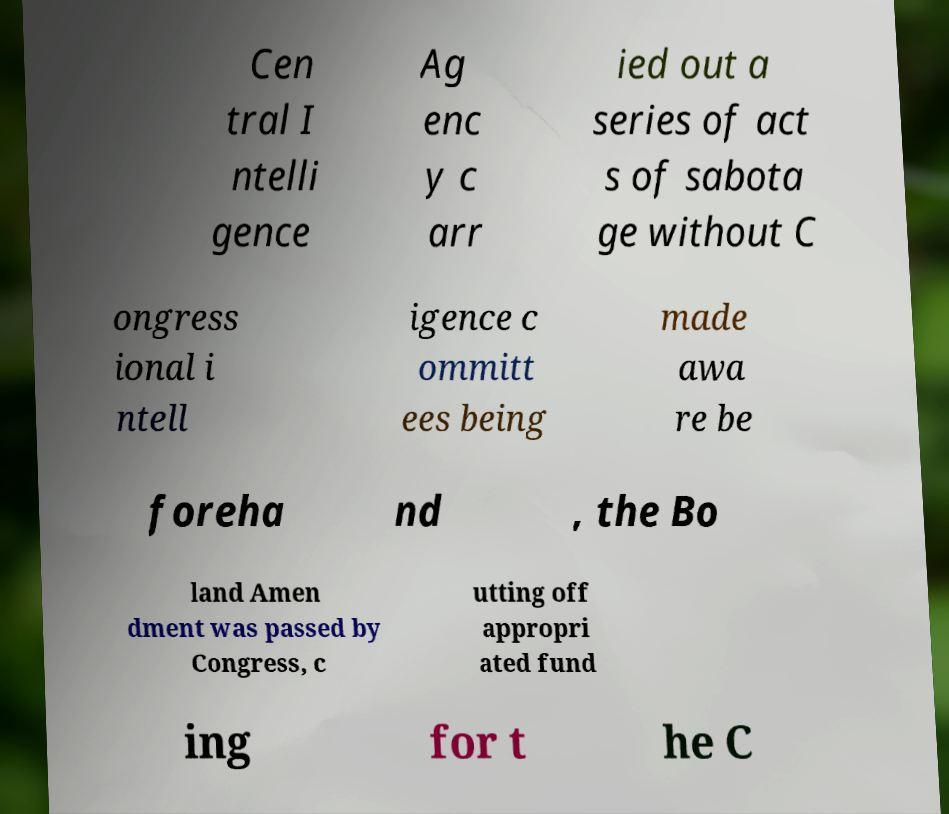For documentation purposes, I need the text within this image transcribed. Could you provide that? Cen tral I ntelli gence Ag enc y c arr ied out a series of act s of sabota ge without C ongress ional i ntell igence c ommitt ees being made awa re be foreha nd , the Bo land Amen dment was passed by Congress, c utting off appropri ated fund ing for t he C 